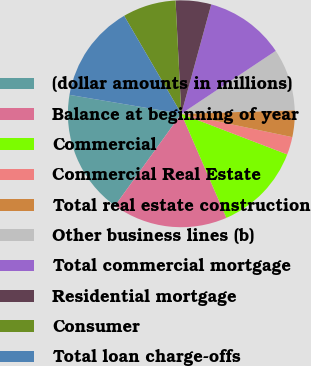<chart> <loc_0><loc_0><loc_500><loc_500><pie_chart><fcel>(dollar amounts in millions)<fcel>Balance at beginning of year<fcel>Commercial<fcel>Commercial Real Estate<fcel>Total real estate construction<fcel>Other business lines (b)<fcel>Total commercial mortgage<fcel>Residential mortgage<fcel>Consumer<fcel>Total loan charge-offs<nl><fcel>17.72%<fcel>16.45%<fcel>12.66%<fcel>2.53%<fcel>3.8%<fcel>8.86%<fcel>11.39%<fcel>5.06%<fcel>7.6%<fcel>13.92%<nl></chart> 